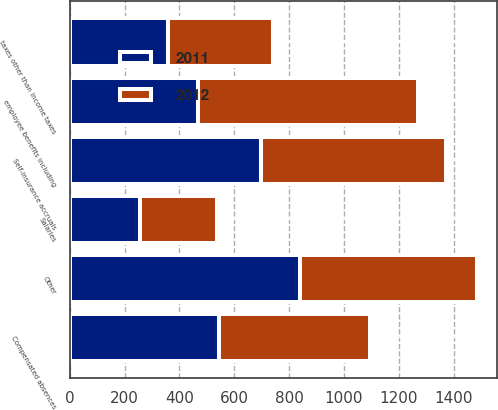Convert chart. <chart><loc_0><loc_0><loc_500><loc_500><stacked_bar_chart><ecel><fcel>Salaries<fcel>employee benefits including<fcel>Compensated absences<fcel>Self-insurance accruals<fcel>taxes other than income taxes<fcel>Other<nl><fcel>2012<fcel>280<fcel>803<fcel>552<fcel>678<fcel>386<fcel>645<nl><fcel>2011<fcel>256<fcel>468<fcel>544<fcel>696<fcel>357<fcel>841<nl></chart> 